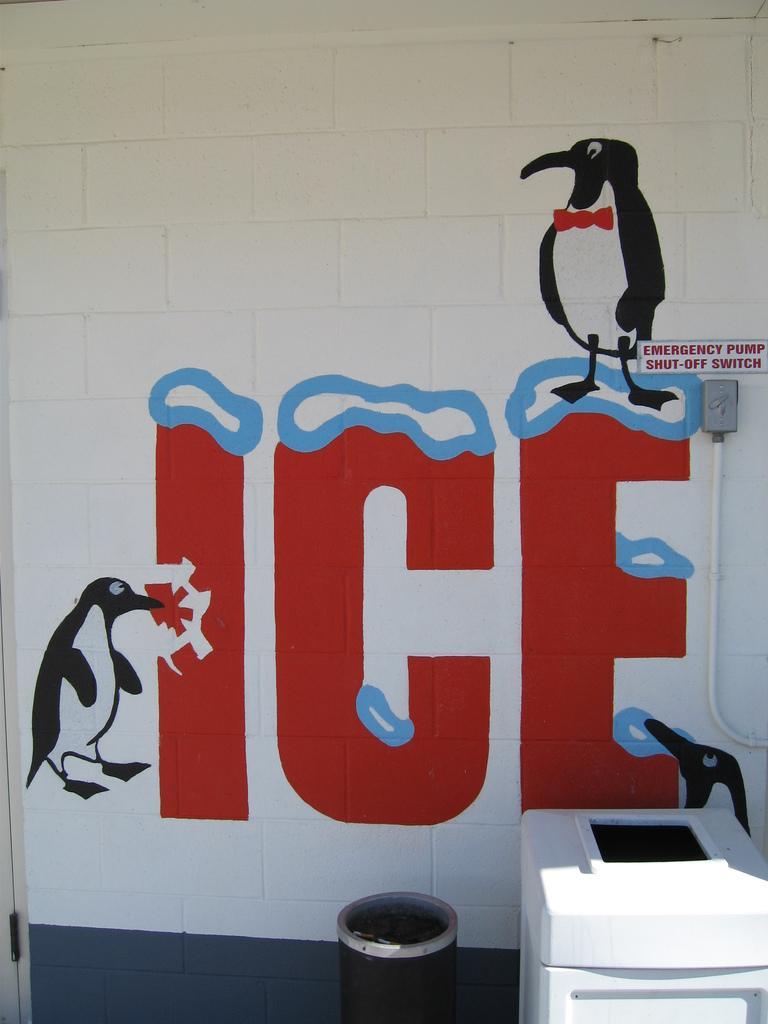Please provide a concise description of this image. In this image I can see the wall and on it I can see something is written. I can also see the depiction of penguins on the wall. On the right side of the image I can see a switch box, a white colour pipe and above the box, I can see something is written. On the bottom side of the image I can see a black and a white colour thing. 